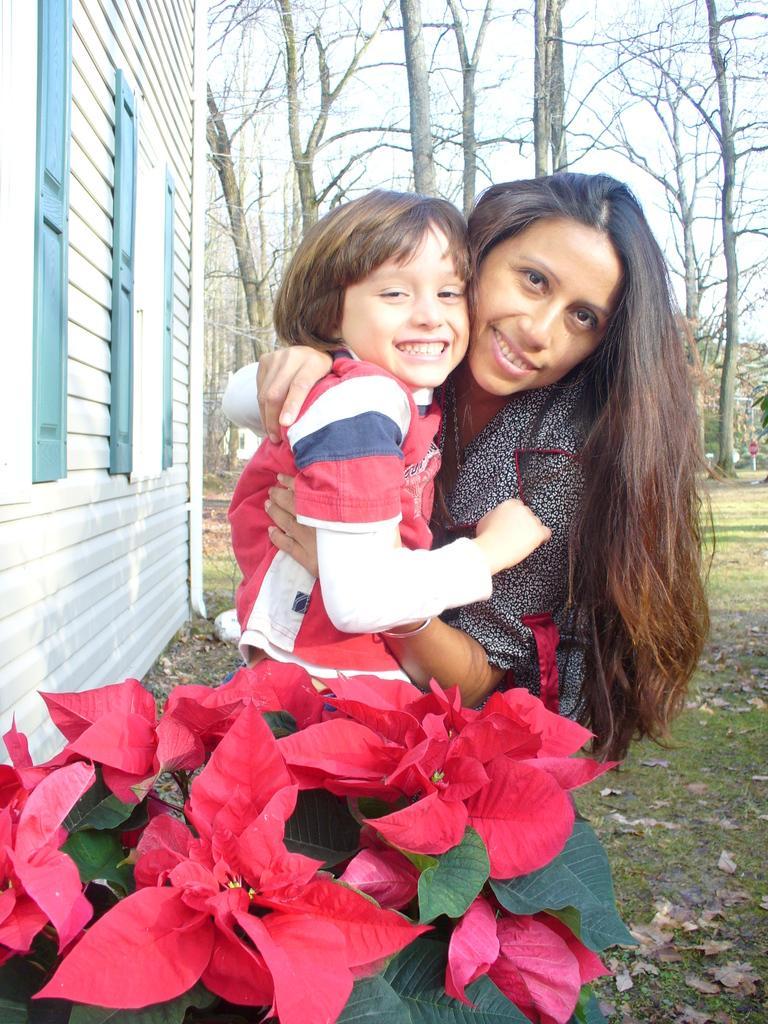In one or two sentences, can you explain what this image depicts? In this image there is one woman who is holding one boy, and there are some leaves and flowers. At the bottom there is grass and some dry leaves and on the left side of the image there is a house, in the background there are trees and sky. 